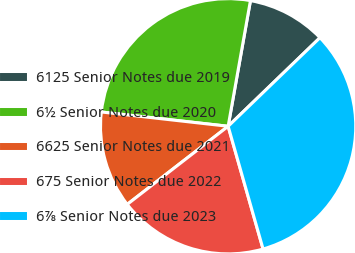Convert chart. <chart><loc_0><loc_0><loc_500><loc_500><pie_chart><fcel>6125 Senior Notes due 2019<fcel>6½ Senior Notes due 2020<fcel>6625 Senior Notes due 2021<fcel>675 Senior Notes due 2022<fcel>6⅞ Senior Notes due 2023<nl><fcel>9.99%<fcel>26.01%<fcel>12.27%<fcel>18.93%<fcel>32.8%<nl></chart> 